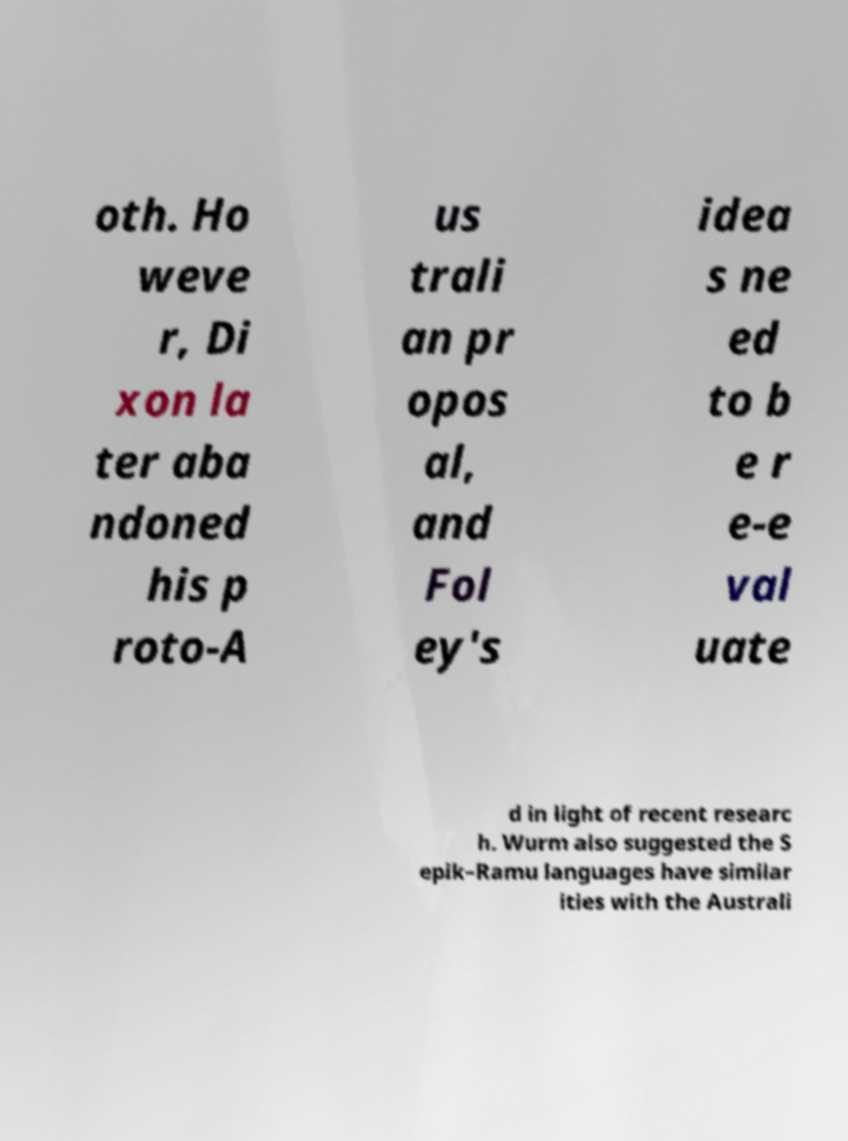What messages or text are displayed in this image? I need them in a readable, typed format. oth. Ho weve r, Di xon la ter aba ndoned his p roto-A us trali an pr opos al, and Fol ey's idea s ne ed to b e r e-e val uate d in light of recent researc h. Wurm also suggested the S epik–Ramu languages have similar ities with the Australi 